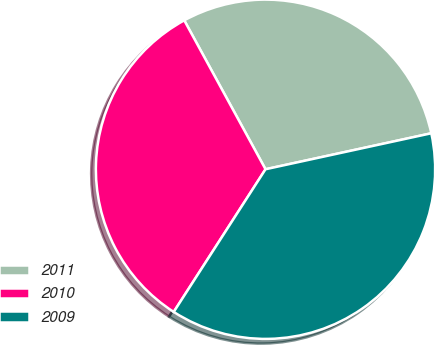<chart> <loc_0><loc_0><loc_500><loc_500><pie_chart><fcel>2011<fcel>2010<fcel>2009<nl><fcel>29.55%<fcel>32.95%<fcel>37.5%<nl></chart> 